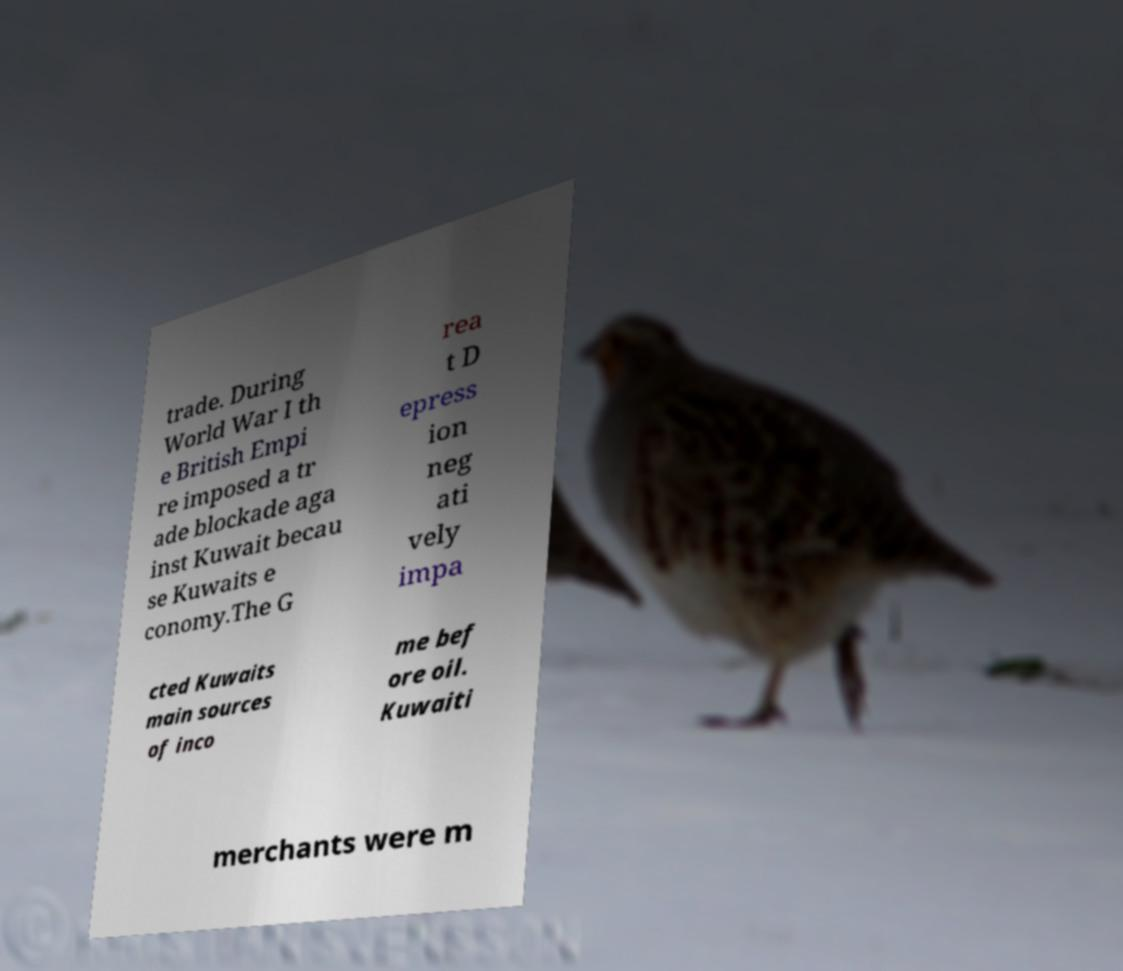Please read and relay the text visible in this image. What does it say? trade. During World War I th e British Empi re imposed a tr ade blockade aga inst Kuwait becau se Kuwaits e conomy.The G rea t D epress ion neg ati vely impa cted Kuwaits main sources of inco me bef ore oil. Kuwaiti merchants were m 